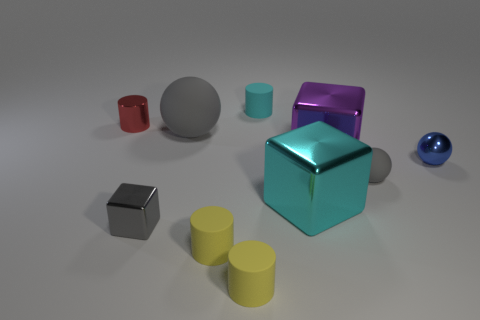How many objects are there in this image, and can you describe their shapes? In the image, there are a total of nine objects, each with a distinct shape. Starting from the left, there's a small red cube, followed by a medium-sized gray cylinder. Next, there's a large blue sphere and behind it, a smaller teal-colored cube. In the center, we see the largest object, a reflective teal cube. To its right, there's a snaller magenta cube, and in front of it, three yellow cylinders of the same diameter but varying heights. On the very right, there's a small blue sphere. 